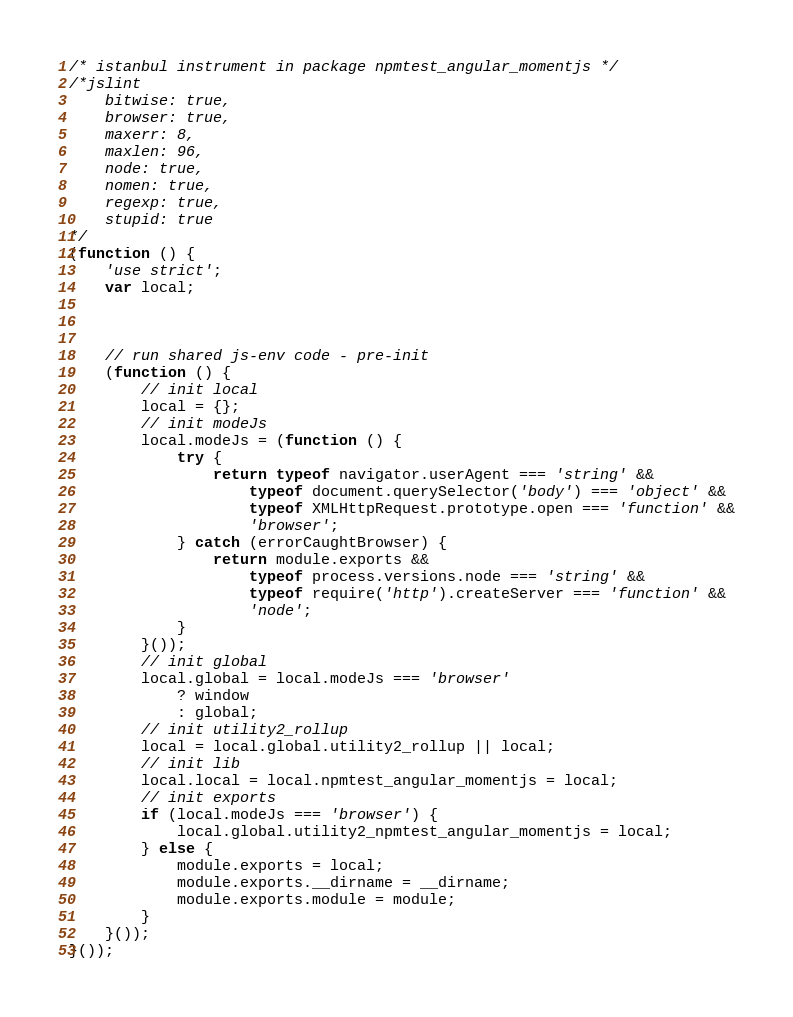<code> <loc_0><loc_0><loc_500><loc_500><_JavaScript_>/* istanbul instrument in package npmtest_angular_momentjs */
/*jslint
    bitwise: true,
    browser: true,
    maxerr: 8,
    maxlen: 96,
    node: true,
    nomen: true,
    regexp: true,
    stupid: true
*/
(function () {
    'use strict';
    var local;



    // run shared js-env code - pre-init
    (function () {
        // init local
        local = {};
        // init modeJs
        local.modeJs = (function () {
            try {
                return typeof navigator.userAgent === 'string' &&
                    typeof document.querySelector('body') === 'object' &&
                    typeof XMLHttpRequest.prototype.open === 'function' &&
                    'browser';
            } catch (errorCaughtBrowser) {
                return module.exports &&
                    typeof process.versions.node === 'string' &&
                    typeof require('http').createServer === 'function' &&
                    'node';
            }
        }());
        // init global
        local.global = local.modeJs === 'browser'
            ? window
            : global;
        // init utility2_rollup
        local = local.global.utility2_rollup || local;
        // init lib
        local.local = local.npmtest_angular_momentjs = local;
        // init exports
        if (local.modeJs === 'browser') {
            local.global.utility2_npmtest_angular_momentjs = local;
        } else {
            module.exports = local;
            module.exports.__dirname = __dirname;
            module.exports.module = module;
        }
    }());
}());
</code> 